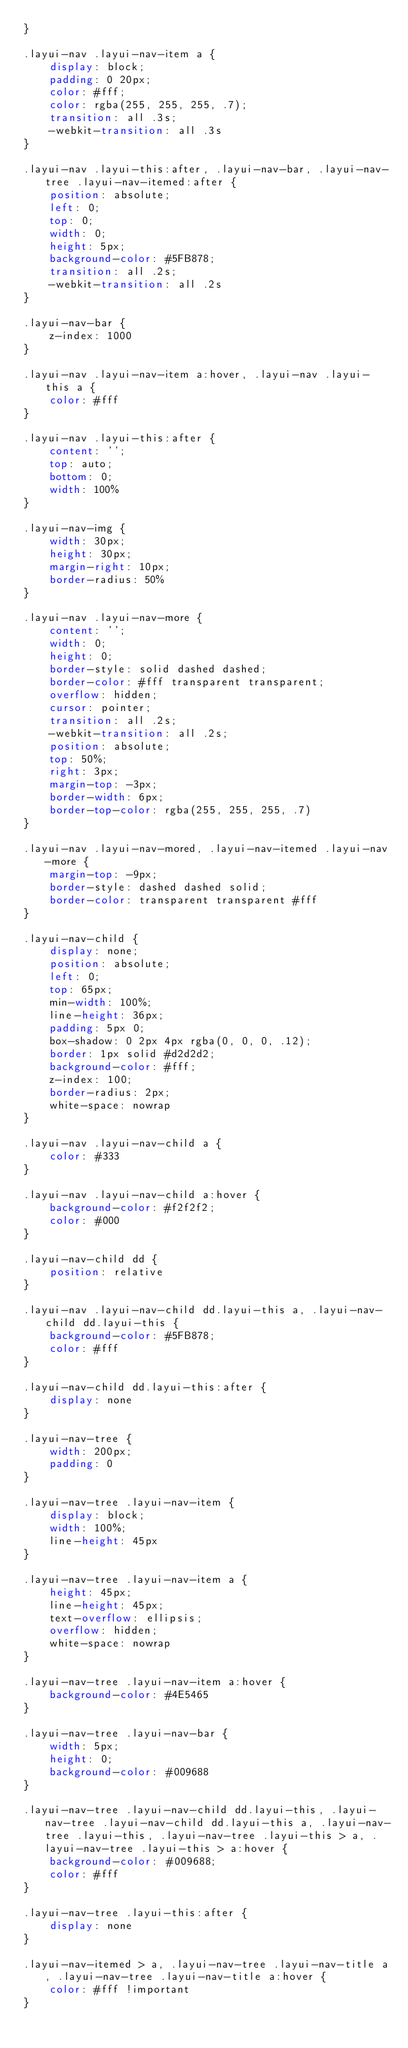<code> <loc_0><loc_0><loc_500><loc_500><_CSS_>}

.layui-nav .layui-nav-item a {
    display: block;
    padding: 0 20px;
    color: #fff;
    color: rgba(255, 255, 255, .7);
    transition: all .3s;
    -webkit-transition: all .3s
}

.layui-nav .layui-this:after, .layui-nav-bar, .layui-nav-tree .layui-nav-itemed:after {
    position: absolute;
    left: 0;
    top: 0;
    width: 0;
    height: 5px;
    background-color: #5FB878;
    transition: all .2s;
    -webkit-transition: all .2s
}

.layui-nav-bar {
    z-index: 1000
}

.layui-nav .layui-nav-item a:hover, .layui-nav .layui-this a {
    color: #fff
}

.layui-nav .layui-this:after {
    content: '';
    top: auto;
    bottom: 0;
    width: 100%
}

.layui-nav-img {
    width: 30px;
    height: 30px;
    margin-right: 10px;
    border-radius: 50%
}

.layui-nav .layui-nav-more {
    content: '';
    width: 0;
    height: 0;
    border-style: solid dashed dashed;
    border-color: #fff transparent transparent;
    overflow: hidden;
    cursor: pointer;
    transition: all .2s;
    -webkit-transition: all .2s;
    position: absolute;
    top: 50%;
    right: 3px;
    margin-top: -3px;
    border-width: 6px;
    border-top-color: rgba(255, 255, 255, .7)
}

.layui-nav .layui-nav-mored, .layui-nav-itemed .layui-nav-more {
    margin-top: -9px;
    border-style: dashed dashed solid;
    border-color: transparent transparent #fff
}

.layui-nav-child {
    display: none;
    position: absolute;
    left: 0;
    top: 65px;
    min-width: 100%;
    line-height: 36px;
    padding: 5px 0;
    box-shadow: 0 2px 4px rgba(0, 0, 0, .12);
    border: 1px solid #d2d2d2;
    background-color: #fff;
    z-index: 100;
    border-radius: 2px;
    white-space: nowrap
}

.layui-nav .layui-nav-child a {
    color: #333
}

.layui-nav .layui-nav-child a:hover {
    background-color: #f2f2f2;
    color: #000
}

.layui-nav-child dd {
    position: relative
}

.layui-nav .layui-nav-child dd.layui-this a, .layui-nav-child dd.layui-this {
    background-color: #5FB878;
    color: #fff
}

.layui-nav-child dd.layui-this:after {
    display: none
}

.layui-nav-tree {
    width: 200px;
    padding: 0
}

.layui-nav-tree .layui-nav-item {
    display: block;
    width: 100%;
    line-height: 45px
}

.layui-nav-tree .layui-nav-item a {
    height: 45px;
    line-height: 45px;
    text-overflow: ellipsis;
    overflow: hidden;
    white-space: nowrap
}

.layui-nav-tree .layui-nav-item a:hover {
    background-color: #4E5465
}

.layui-nav-tree .layui-nav-bar {
    width: 5px;
    height: 0;
    background-color: #009688
}

.layui-nav-tree .layui-nav-child dd.layui-this, .layui-nav-tree .layui-nav-child dd.layui-this a, .layui-nav-tree .layui-this, .layui-nav-tree .layui-this > a, .layui-nav-tree .layui-this > a:hover {
    background-color: #009688;
    color: #fff
}

.layui-nav-tree .layui-this:after {
    display: none
}

.layui-nav-itemed > a, .layui-nav-tree .layui-nav-title a, .layui-nav-tree .layui-nav-title a:hover {
    color: #fff !important
}
</code> 